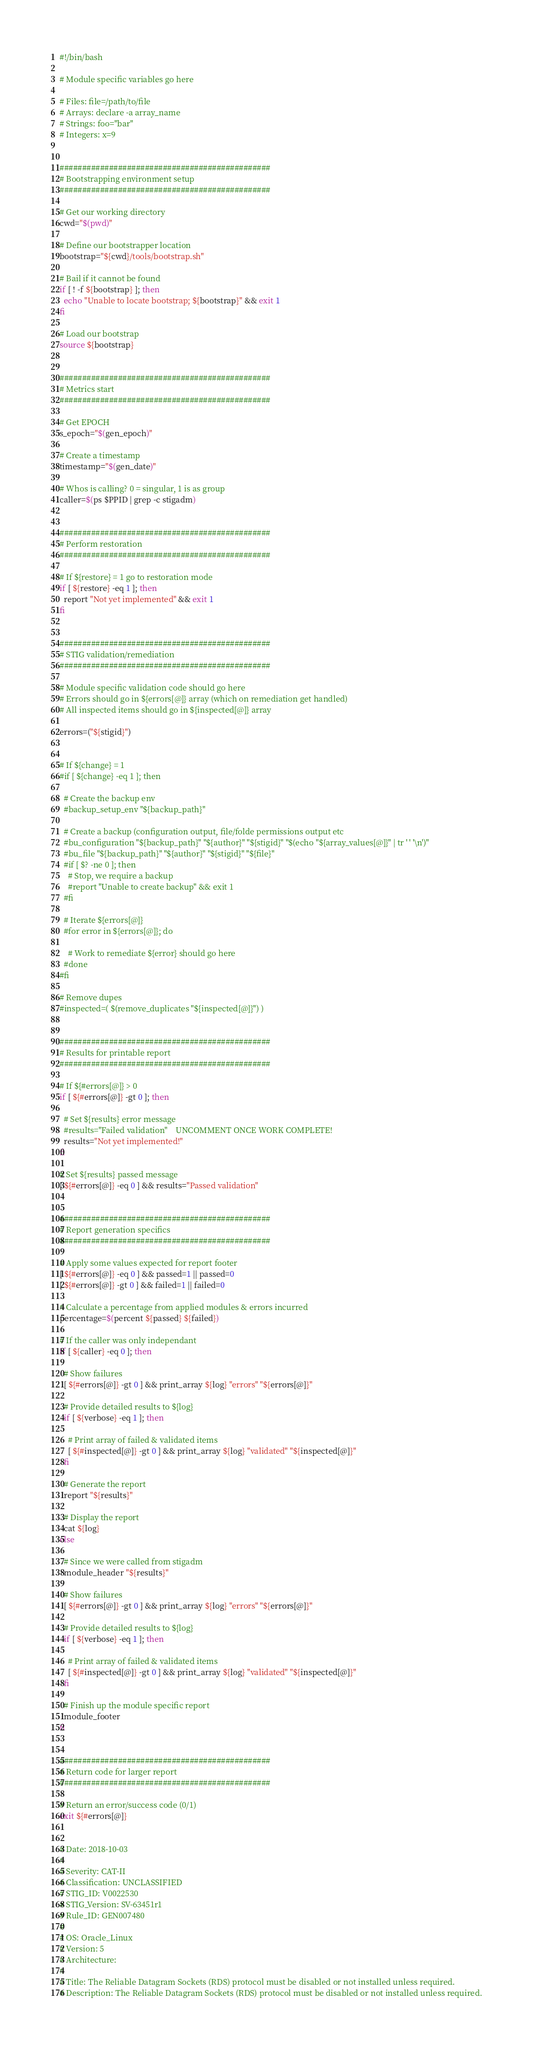<code> <loc_0><loc_0><loc_500><loc_500><_Bash_>#!/bin/bash

# Module specific variables go here

# Files: file=/path/to/file
# Arrays: declare -a array_name
# Strings: foo="bar"
# Integers: x=9


###############################################
# Bootstrapping environment setup
###############################################

# Get our working directory
cwd="$(pwd)"

# Define our bootstrapper location
bootstrap="${cwd}/tools/bootstrap.sh"

# Bail if it cannot be found
if [ ! -f ${bootstrap} ]; then
  echo "Unable to locate bootstrap; ${bootstrap}" && exit 1
fi

# Load our bootstrap
source ${bootstrap}


###############################################
# Metrics start
###############################################

# Get EPOCH
s_epoch="$(gen_epoch)"

# Create a timestamp
timestamp="$(gen_date)"

# Whos is calling? 0 = singular, 1 is as group
caller=$(ps $PPID | grep -c stigadm)


###############################################
# Perform restoration
###############################################

# If ${restore} = 1 go to restoration mode
if [ ${restore} -eq 1 ]; then
  report "Not yet implemented" && exit 1
fi


###############################################
# STIG validation/remediation
###############################################

# Module specific validation code should go here
# Errors should go in ${errors[@]} array (which on remediation get handled)
# All inspected items should go in ${inspected[@]} array

errors=("${stigid}")


# If ${change} = 1
#if [ ${change} -eq 1 ]; then

  # Create the backup env
  #backup_setup_env "${backup_path}"

  # Create a backup (configuration output, file/folde permissions output etc
  #bu_configuration "${backup_path}" "${author}" "${stigid}" "$(echo "${array_values[@]}" | tr ' ' '\n')"
  #bu_file "${backup_path}" "${author}" "${stigid}" "${file}"
  #if [ $? -ne 0 ]; then
    # Stop, we require a backup
    #report "Unable to create backup" && exit 1
  #fi

  # Iterate ${errors[@]}
  #for error in ${errors[@]}; do

    # Work to remediate ${error} should go here
  #done
#fi

# Remove dupes
#inspected=( $(remove_duplicates "${inspected[@]}") )


###############################################
# Results for printable report
###############################################

# If ${#errors[@]} > 0
if [ ${#errors[@]} -gt 0 ]; then

  # Set ${results} error message
  #results="Failed validation"    UNCOMMENT ONCE WORK COMPLETE!
  results="Not yet implemented!"
fi

# Set ${results} passed message
[ ${#errors[@]} -eq 0 ] && results="Passed validation"


###############################################
# Report generation specifics
###############################################

# Apply some values expected for report footer
[ ${#errors[@]} -eq 0 ] && passed=1 || passed=0
[ ${#errors[@]} -gt 0 ] && failed=1 || failed=0

# Calculate a percentage from applied modules & errors incurred
percentage=$(percent ${passed} ${failed})

# If the caller was only independant
if [ ${caller} -eq 0 ]; then

  # Show failures
  [ ${#errors[@]} -gt 0 ] && print_array ${log} "errors" "${errors[@]}"

  # Provide detailed results to ${log}
  if [ ${verbose} -eq 1 ]; then

    # Print array of failed & validated items
    [ ${#inspected[@]} -gt 0 ] && print_array ${log} "validated" "${inspected[@]}"
  fi

  # Generate the report
  report "${results}"

  # Display the report
  cat ${log}
else

  # Since we were called from stigadm
  module_header "${results}"

  # Show failures
  [ ${#errors[@]} -gt 0 ] && print_array ${log} "errors" "${errors[@]}"

  # Provide detailed results to ${log}
  if [ ${verbose} -eq 1 ]; then

    # Print array of failed & validated items
    [ ${#inspected[@]} -gt 0 ] && print_array ${log} "validated" "${inspected[@]}"
  fi

  # Finish up the module specific report
  module_footer
fi


###############################################
# Return code for larger report
###############################################

# Return an error/success code (0/1)
exit ${#errors[@]}


# Date: 2018-10-03
#
# Severity: CAT-II
# Classification: UNCLASSIFIED
# STIG_ID: V0022530
# STIG_Version: SV-63451r1
# Rule_ID: GEN007480
#
# OS: Oracle_Linux
# Version: 5
# Architecture: 
#
# Title: The Reliable Datagram Sockets (RDS) protocol must be disabled or not installed unless required.
# Description: The Reliable Datagram Sockets (RDS) protocol must be disabled or not installed unless required.

</code> 